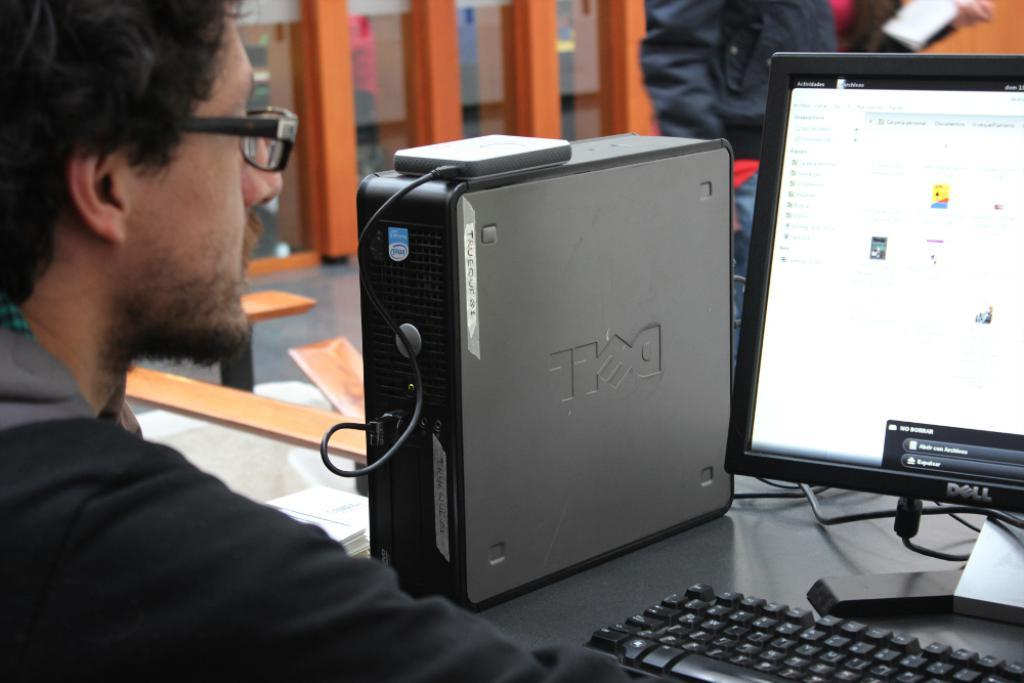<image>
Offer a succinct explanation of the picture presented. A man working on a computer with a tower that indicates it is a DELL brand computer. 